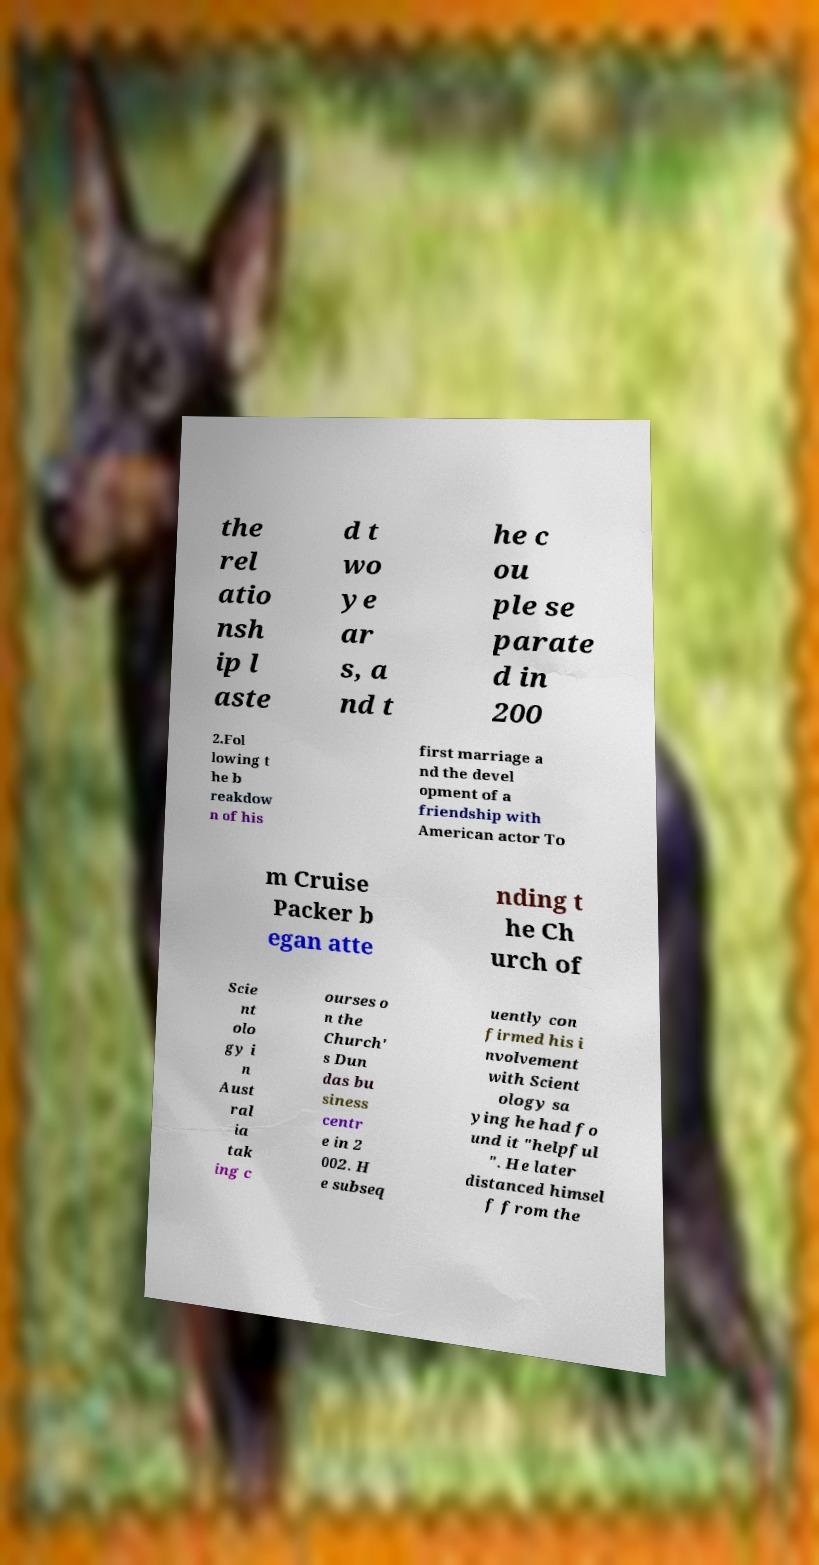There's text embedded in this image that I need extracted. Can you transcribe it verbatim? the rel atio nsh ip l aste d t wo ye ar s, a nd t he c ou ple se parate d in 200 2.Fol lowing t he b reakdow n of his first marriage a nd the devel opment of a friendship with American actor To m Cruise Packer b egan atte nding t he Ch urch of Scie nt olo gy i n Aust ral ia tak ing c ourses o n the Church' s Dun das bu siness centr e in 2 002. H e subseq uently con firmed his i nvolvement with Scient ology sa ying he had fo und it "helpful ". He later distanced himsel f from the 